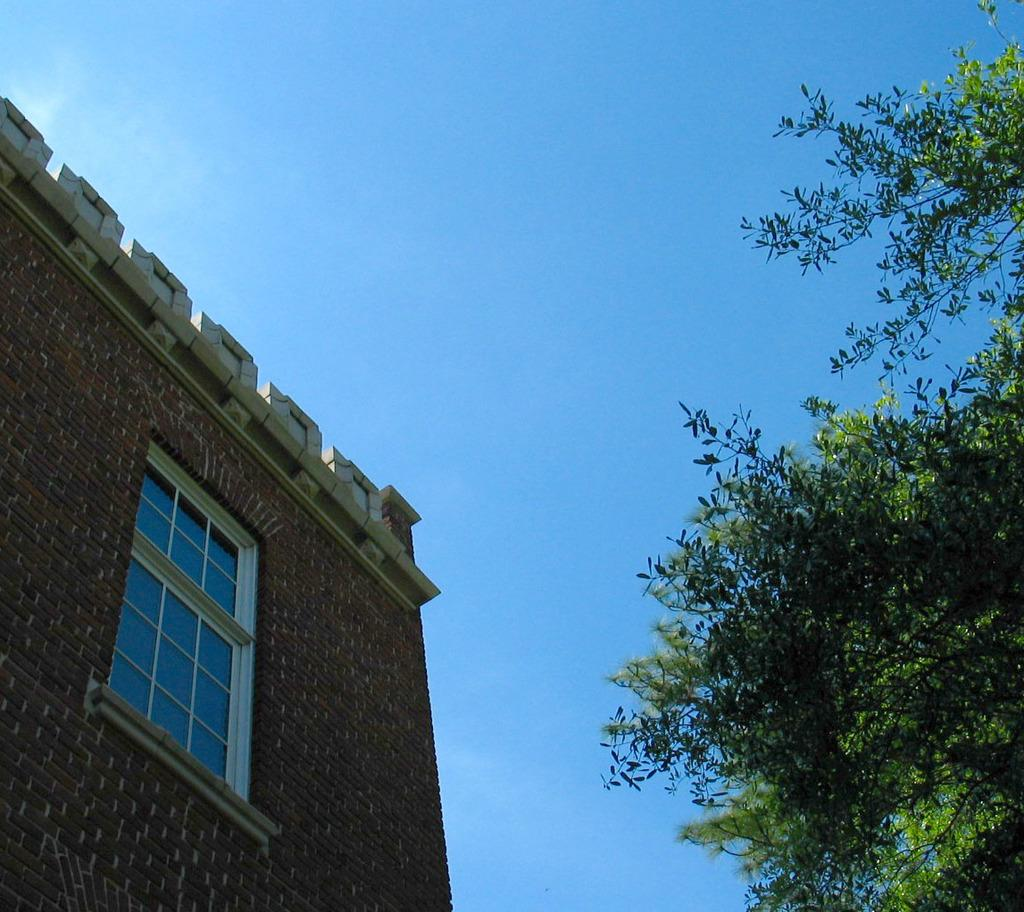What type of vegetation is on the right side of the image? There is a tree on the right side of the image. What type of structure is on the left side of the image? There is a building on the left side of the image. What is visible at the top of the image? The sky is visible at the top of the image. What type of paste is being used to paint the tree in the image? There is no indication of any painting or paste in the image; it simply shows a tree and a building. 